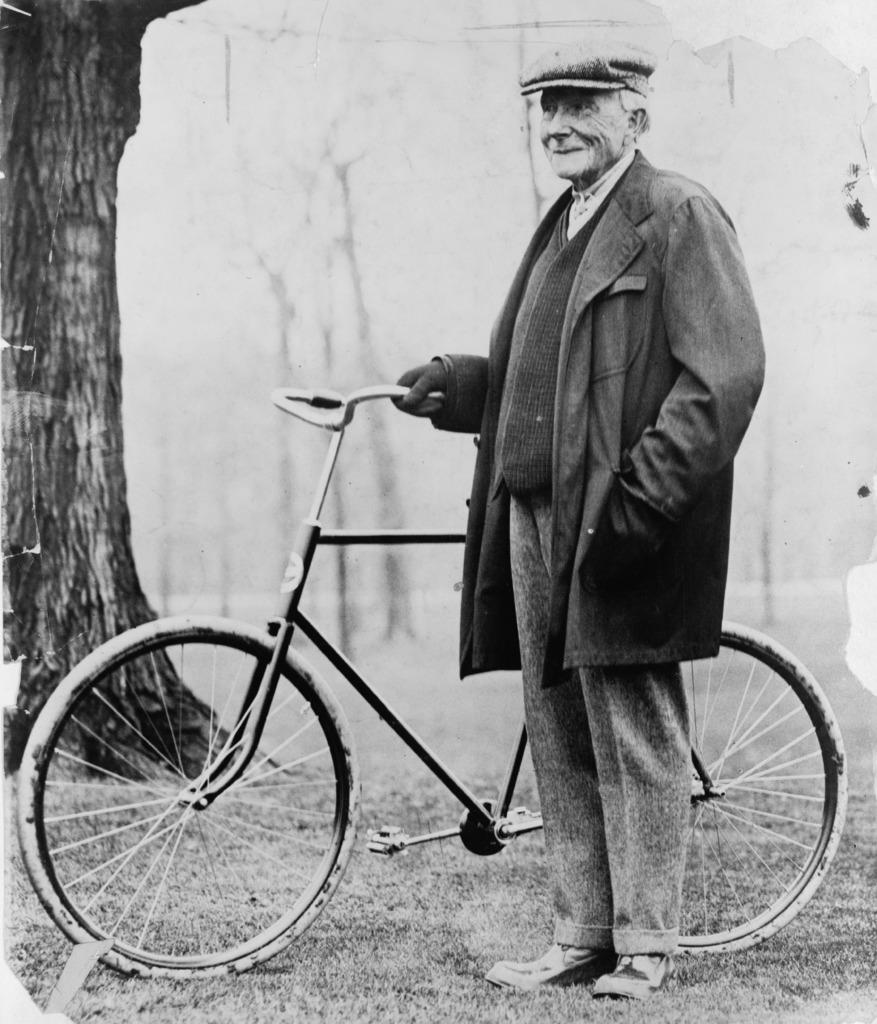Who is the main subject in the image? There is an old man in the image. What is the old man holding in the image? The old man is holding a bicycle. What type of clothing is the old man wearing on his head? The old man is wearing a hat. What type of clothing is the old man wearing on his upper body? The old man is wearing a blazer. What can be seen in the background of the image? There are trees in the background of the image. What type of fowl can be seen participating in the battle in the image? There is no fowl or battle present in the image; it features an old man holding a bicycle. What type of soda is the old man drinking in the image? There is no soda present in the image; the old man is holding a bicycle. 